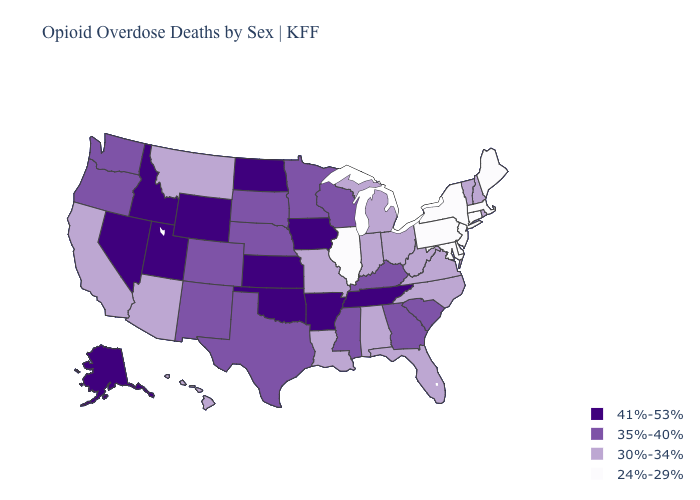What is the value of Illinois?
Give a very brief answer. 24%-29%. Name the states that have a value in the range 30%-34%?
Be succinct. Alabama, Arizona, California, Florida, Hawaii, Indiana, Louisiana, Michigan, Missouri, Montana, New Hampshire, North Carolina, Ohio, Rhode Island, Vermont, Virginia, West Virginia. What is the lowest value in states that border California?
Concise answer only. 30%-34%. Name the states that have a value in the range 30%-34%?
Keep it brief. Alabama, Arizona, California, Florida, Hawaii, Indiana, Louisiana, Michigan, Missouri, Montana, New Hampshire, North Carolina, Ohio, Rhode Island, Vermont, Virginia, West Virginia. What is the highest value in the USA?
Give a very brief answer. 41%-53%. Which states have the lowest value in the USA?
Quick response, please. Connecticut, Delaware, Illinois, Maine, Maryland, Massachusetts, New Jersey, New York, Pennsylvania. Which states hav the highest value in the South?
Write a very short answer. Arkansas, Oklahoma, Tennessee. Which states have the highest value in the USA?
Keep it brief. Alaska, Arkansas, Idaho, Iowa, Kansas, Nevada, North Dakota, Oklahoma, Tennessee, Utah, Wyoming. Does New Jersey have the lowest value in the USA?
Write a very short answer. Yes. Name the states that have a value in the range 30%-34%?
Concise answer only. Alabama, Arizona, California, Florida, Hawaii, Indiana, Louisiana, Michigan, Missouri, Montana, New Hampshire, North Carolina, Ohio, Rhode Island, Vermont, Virginia, West Virginia. Does California have the lowest value in the West?
Be succinct. Yes. Name the states that have a value in the range 24%-29%?
Answer briefly. Connecticut, Delaware, Illinois, Maine, Maryland, Massachusetts, New Jersey, New York, Pennsylvania. Does Wyoming have a lower value than Kentucky?
Quick response, please. No. What is the highest value in the West ?
Write a very short answer. 41%-53%. How many symbols are there in the legend?
Quick response, please. 4. 